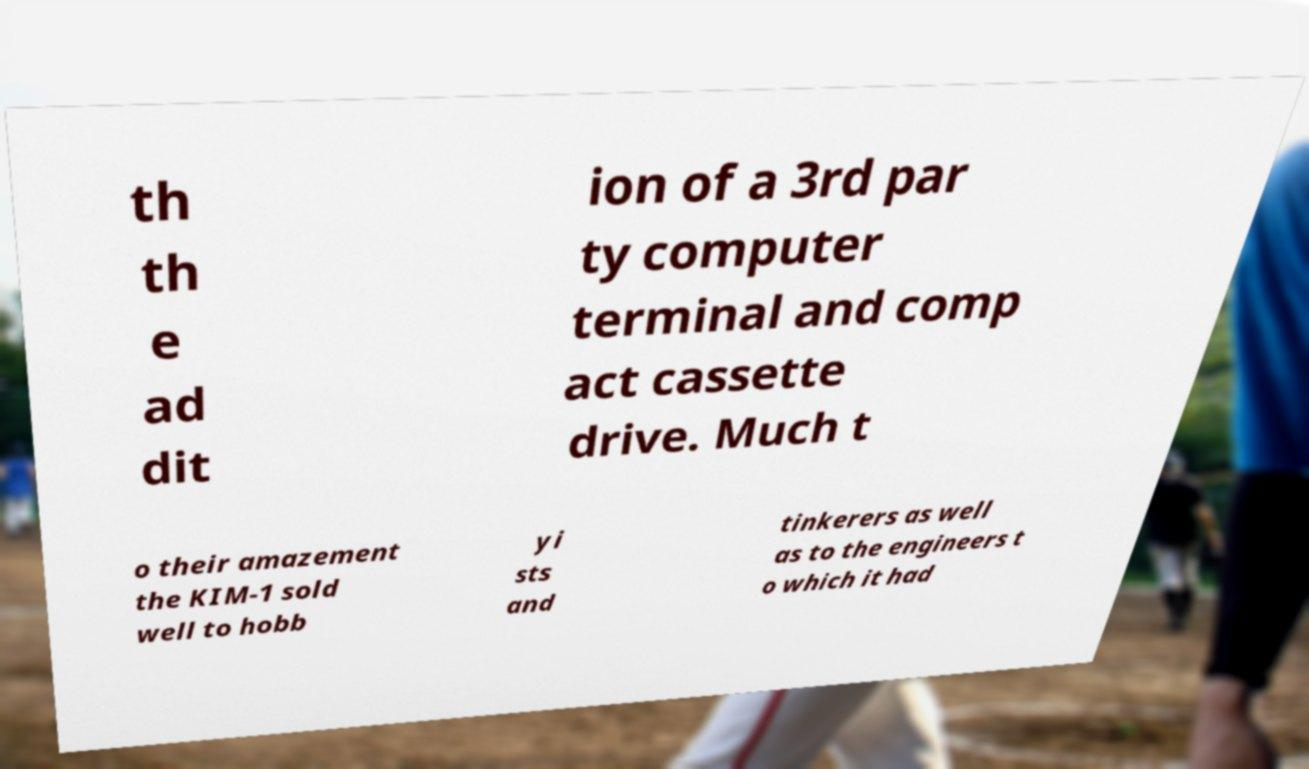Can you read and provide the text displayed in the image?This photo seems to have some interesting text. Can you extract and type it out for me? th th e ad dit ion of a 3rd par ty computer terminal and comp act cassette drive. Much t o their amazement the KIM-1 sold well to hobb yi sts and tinkerers as well as to the engineers t o which it had 